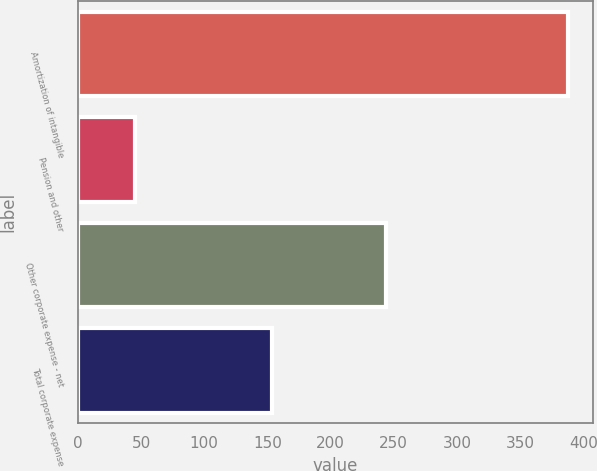<chart> <loc_0><loc_0><loc_500><loc_500><bar_chart><fcel>Amortization of intangible<fcel>Pension and other<fcel>Other corporate expense - net<fcel>Total corporate expense<nl><fcel>388<fcel>45<fcel>244<fcel>154<nl></chart> 